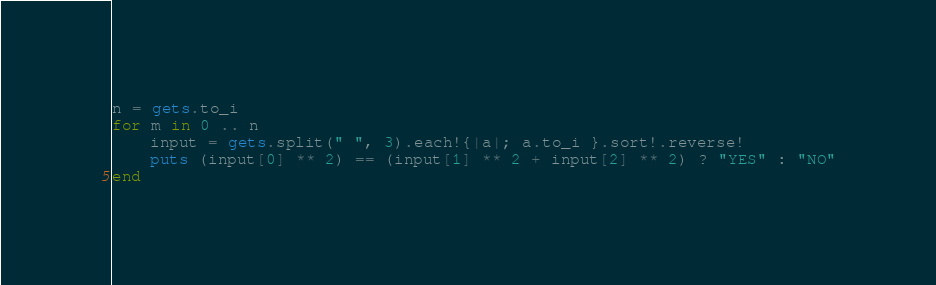Convert code to text. <code><loc_0><loc_0><loc_500><loc_500><_Ruby_>n = gets.to_i
for m in 0 .. n
	input = gets.split(" ", 3).each!{|a|; a.to_i }.sort!.reverse!
	puts (input[0] ** 2) == (input[1] ** 2 + input[2] ** 2) ? "YES" : "NO"
end</code> 